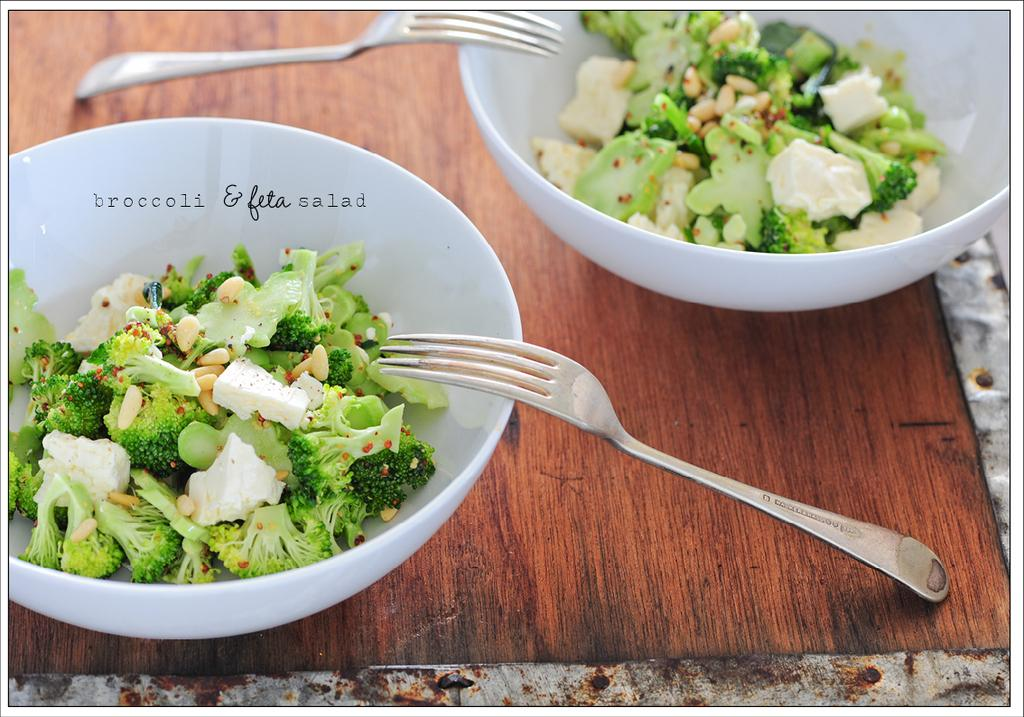How many bowls are visible in the image? There are two bowls in the image. What is inside the bowls? There are pieces of broccoli and other food present in the bowls. How many utensils can be seen in the image? There are two forks in the image. What is the primary surface visible in the image? There is a table at the bottom of the image. What type of invention is being used to cut the lettuce in the image? There is no lettuce present in the image, and no invention is being used to cut it. 